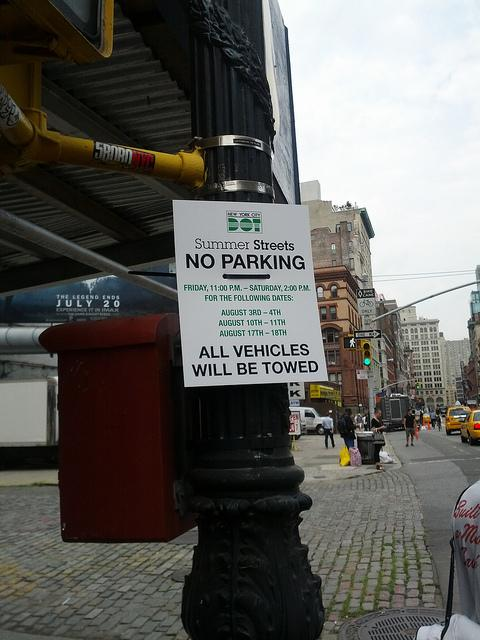What is the green on the bricks on the ground?

Choices:
A) paint
B) crayon
C) apple
D) moss moss 